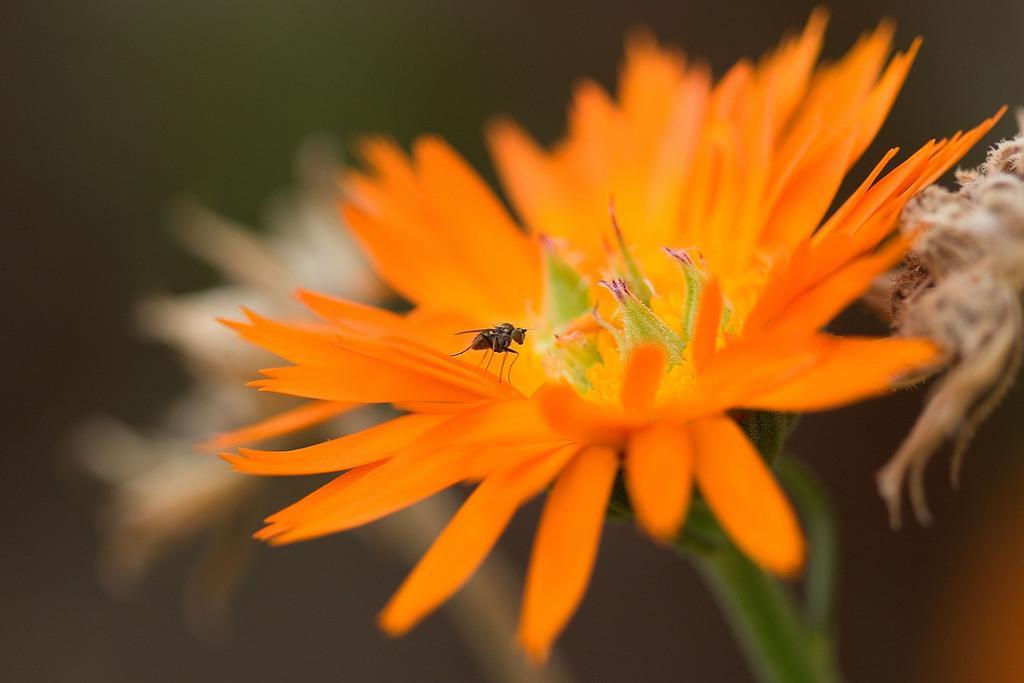Can you describe this image briefly? In this picture I can observe an orange color flower. There is a fly on the flower. The background is completely blurred. 